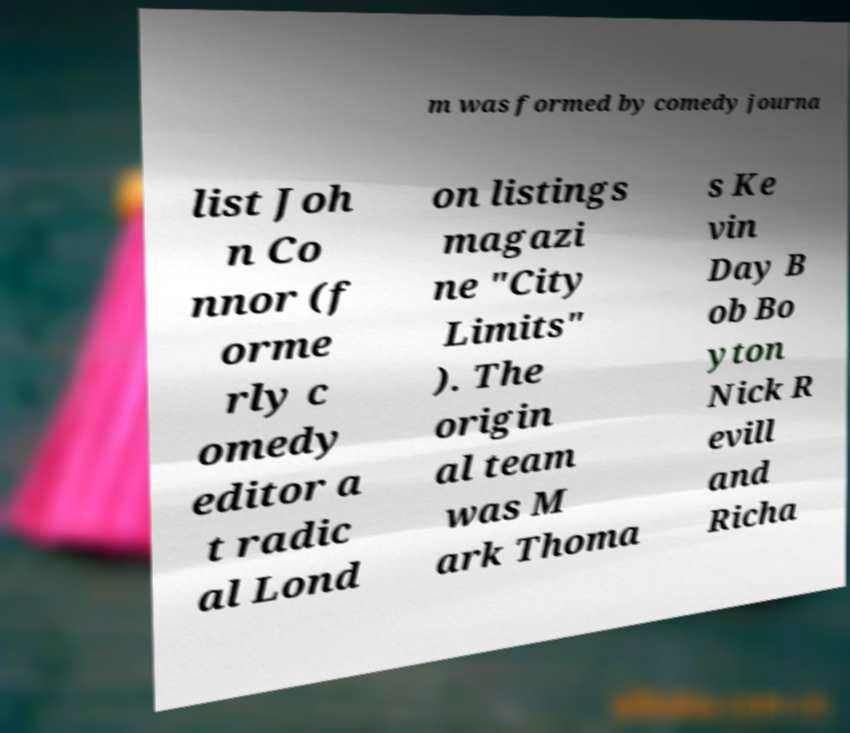Could you assist in decoding the text presented in this image and type it out clearly? m was formed by comedy journa list Joh n Co nnor (f orme rly c omedy editor a t radic al Lond on listings magazi ne "City Limits" ). The origin al team was M ark Thoma s Ke vin Day B ob Bo yton Nick R evill and Richa 